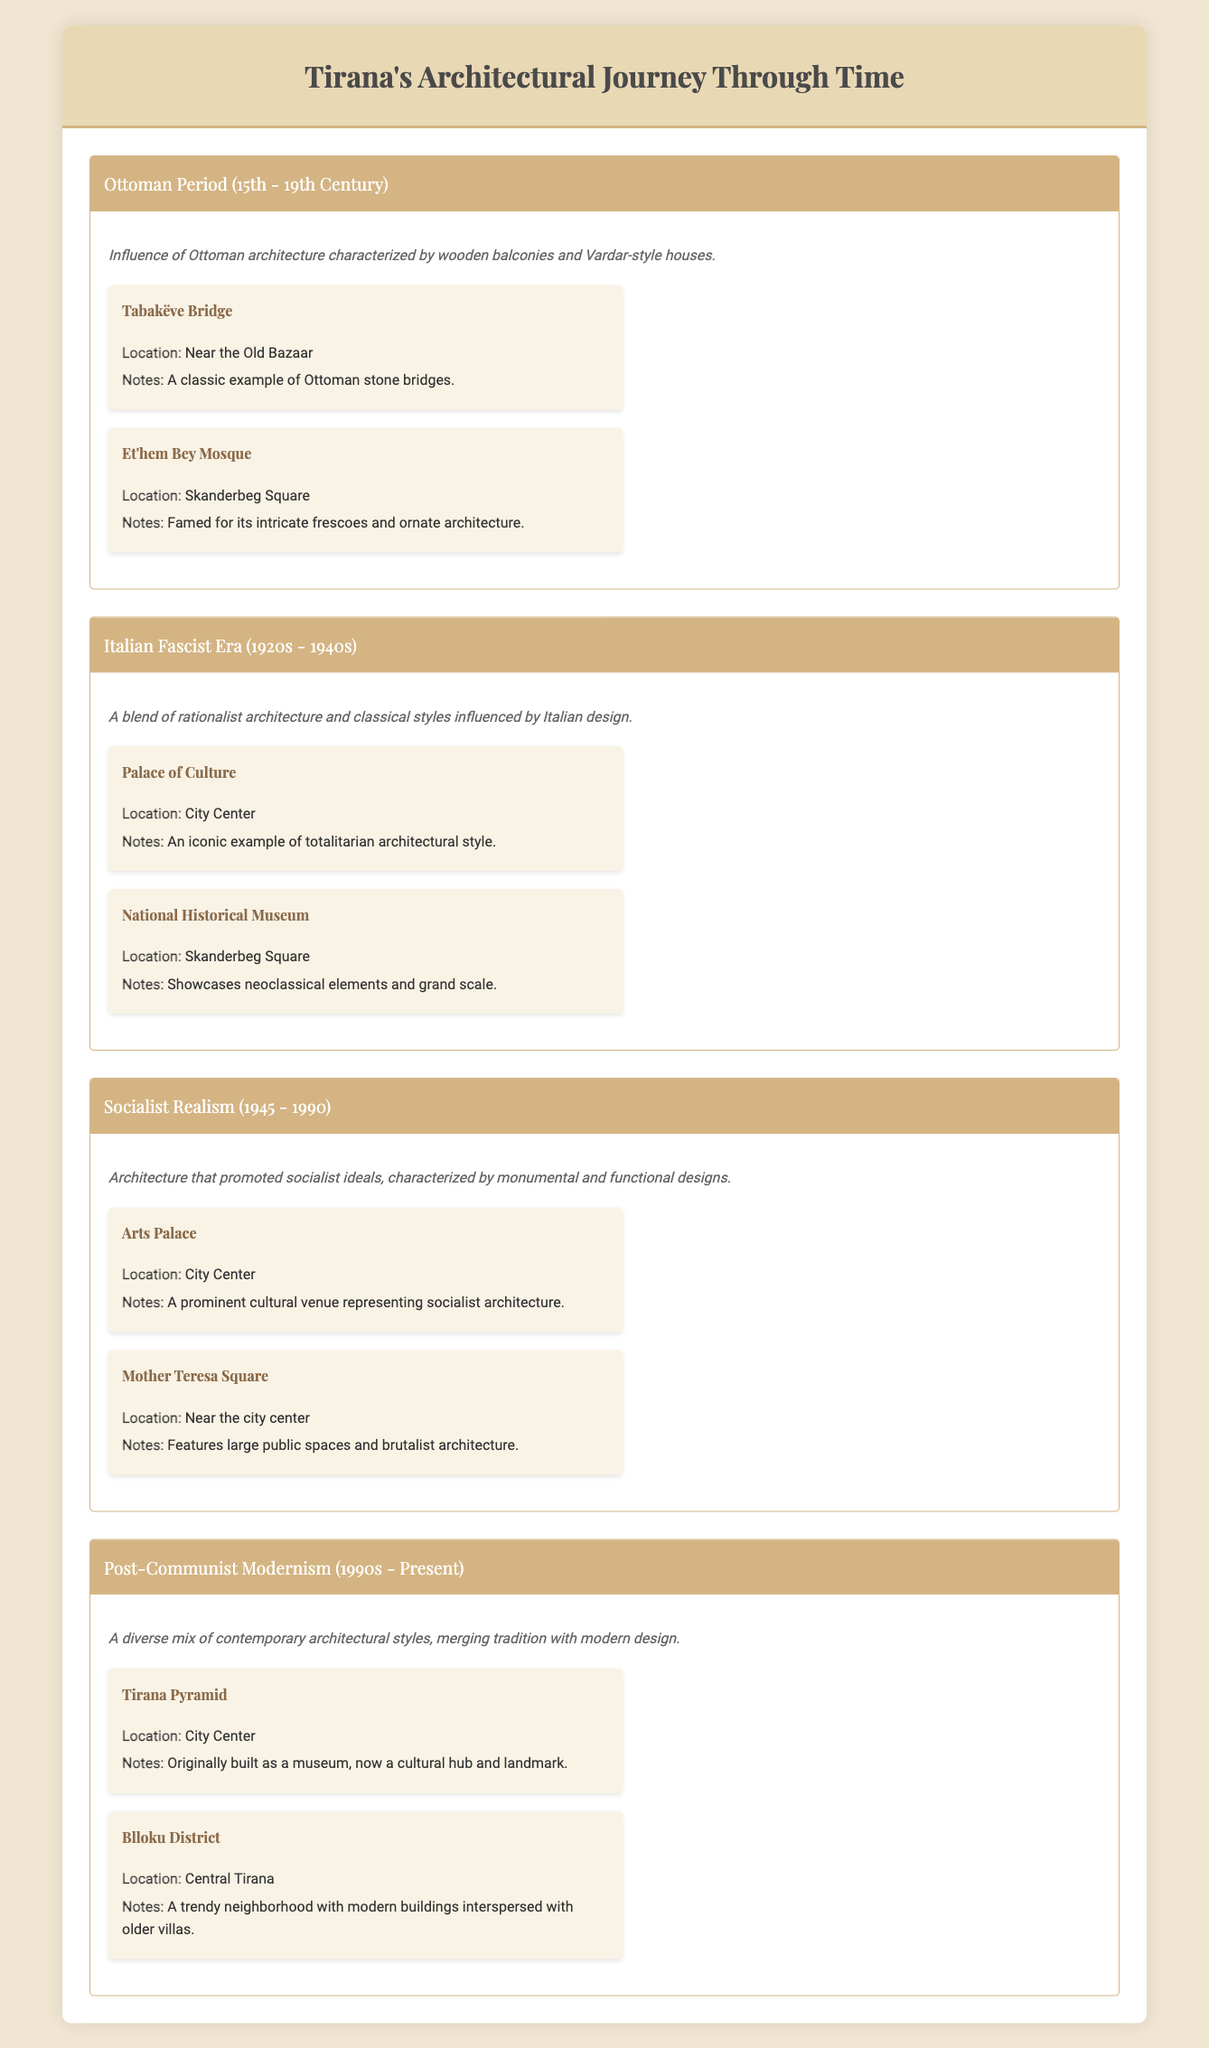What are the architectural styles represented in Tirana? The table lists four architectural styles: Ottoman Period, Italian Fascist Era, Socialist Realism, and Post-Communist Modernism.
Answer: Ottoman Period, Italian Fascist Era, Socialist Realism, Post-Communist Modernism Which architectural style features examples from the period 1945 to 1990? The table indicates that the architectural style from 1945 to 1990 is Socialist Realism, which includes the Arts Palace and Mother Teresa Square as examples.
Answer: Socialist Realism How many key examples are listed for the Italian Fascist Era? The Italian Fascist Era contains two key examples: the Palace of Culture and the National Historical Museum.
Answer: 2 Does the Et'hem Bey Mosque belong to the Post-Communist Modernism style? According to the table, the Et'hem Bey Mosque is associated with the Ottoman Period, not Post-Communist Modernism, making this statement false.
Answer: No What is the main architectural characteristic of the Ottoman Period? The Ottoman Period is described as having an influence characterized by wooden balconies and Vardar-style houses, highlighting its distinctive architecture.
Answer: Wooden balconies and Vardar-style houses Which architectural era includes examples with neoclassical elements? The Italian Fascist Era is noted for showcasing neoclassical elements, particularly in the National Historical Museum.
Answer: Italian Fascist Era In which location can the Tirana Pyramid be found? The table specifies that the Tirana Pyramid is located in the City Center of Tirana.
Answer: City Center How many styles mentioned in the table incorporate elements that promote a specific ideology? Two styles focus on promoting ideologies: Socialist Realism (promoting socialist ideals) and the Italian Fascist Era (reflecting totalitarian ideology).
Answer: 2 What is the difference in locations for the Arts Palace and the Mother Teresa Square? The Arts Palace is located in the City Center, while Mother Teresa Square is near the city center. Thus, they are both central but not in the exact same location.
Answer: Arts Palace: City Center, Mother Teresa Square: Near city center 